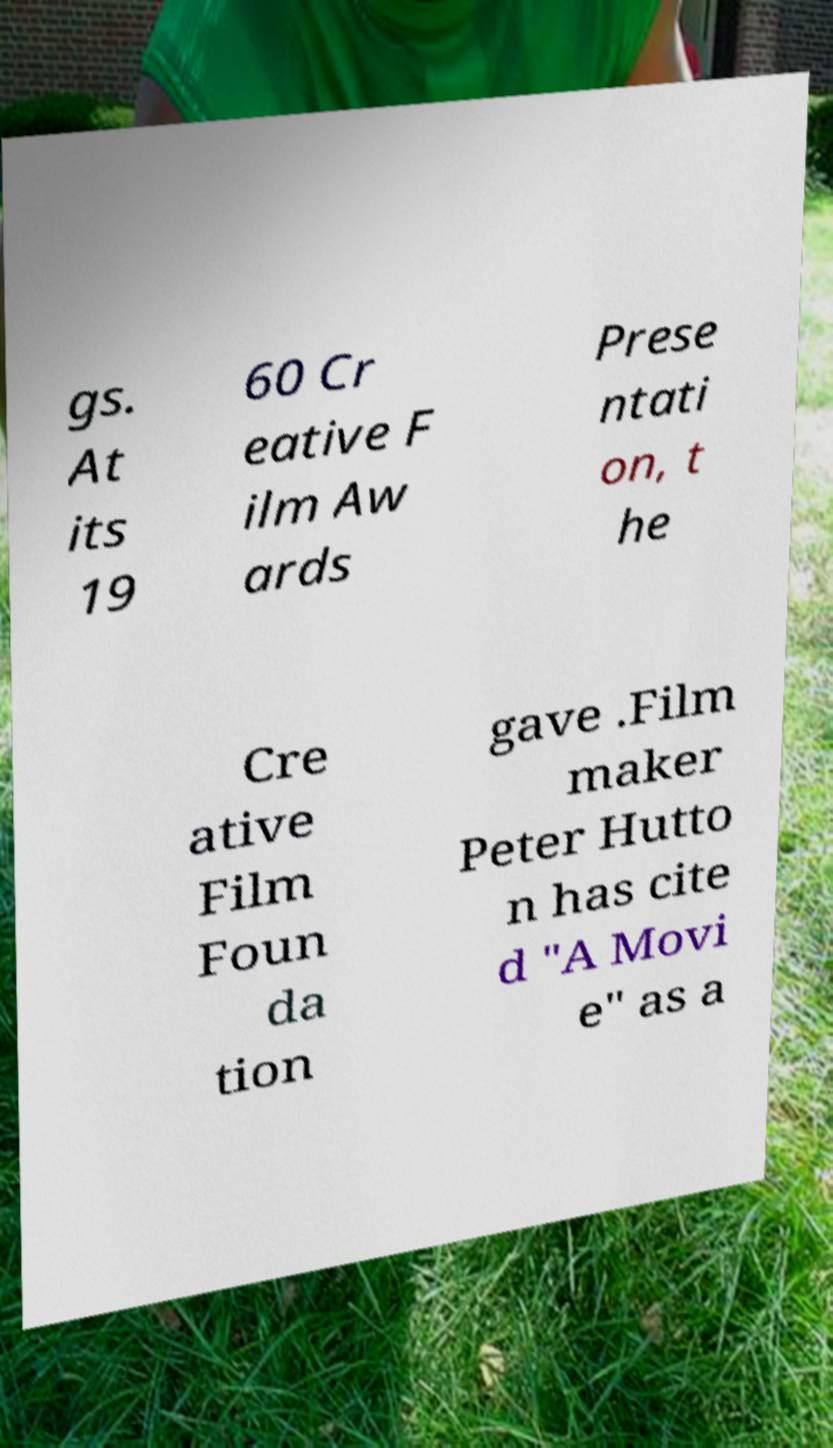Please identify and transcribe the text found in this image. gs. At its 19 60 Cr eative F ilm Aw ards Prese ntati on, t he Cre ative Film Foun da tion gave .Film maker Peter Hutto n has cite d "A Movi e" as a 